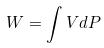<formula> <loc_0><loc_0><loc_500><loc_500>W = \int V d P</formula> 